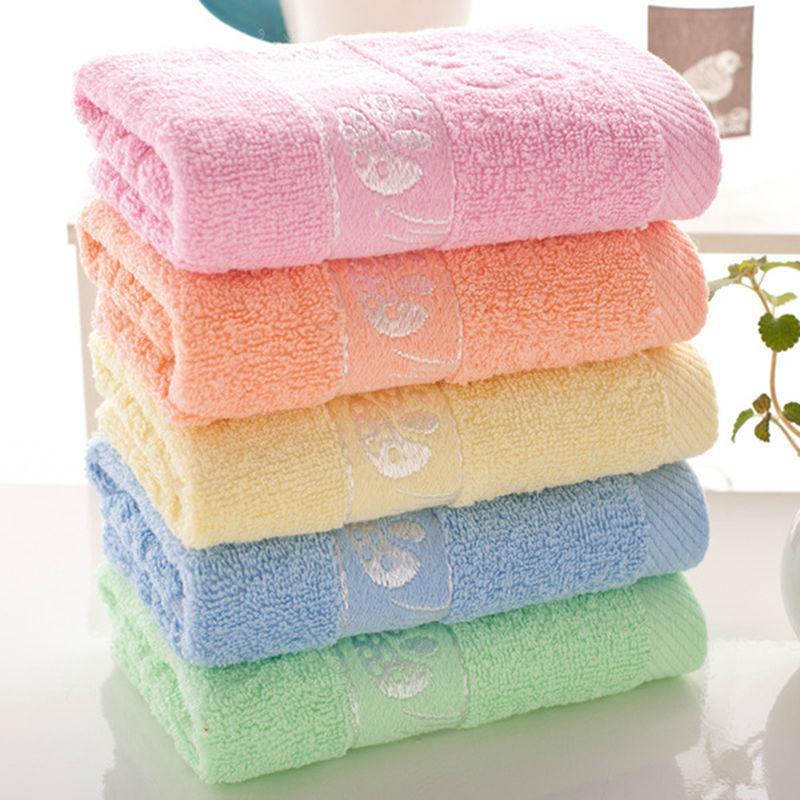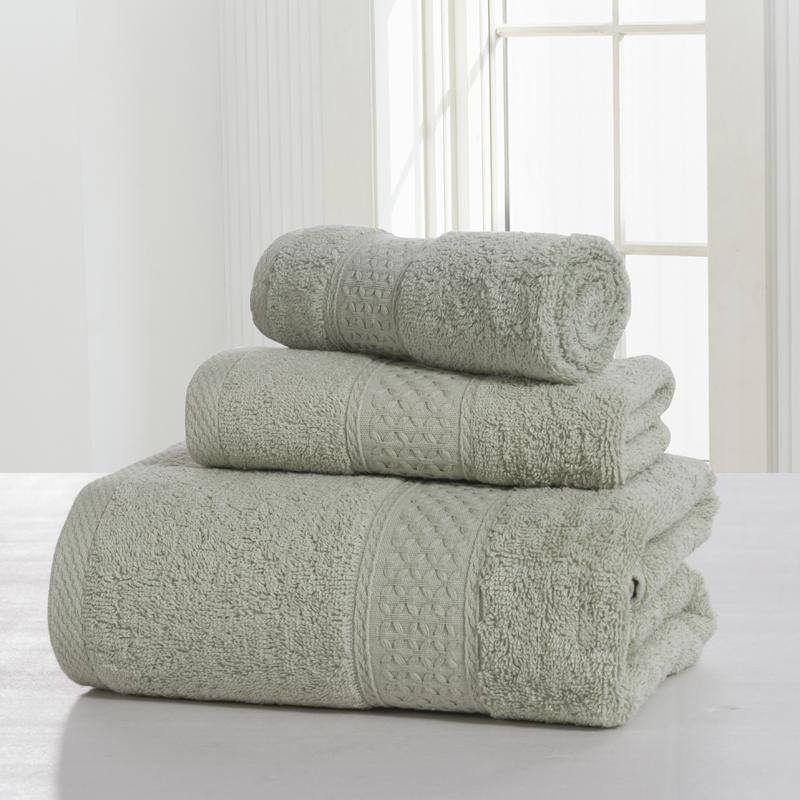The first image is the image on the left, the second image is the image on the right. Analyze the images presented: Is the assertion "There is a stack of all pink towels in one image." valid? Answer yes or no. No. The first image is the image on the left, the second image is the image on the right. Considering the images on both sides, is "The stack of towels in one of the pictures is made up of only identical sized towels." valid? Answer yes or no. Yes. 